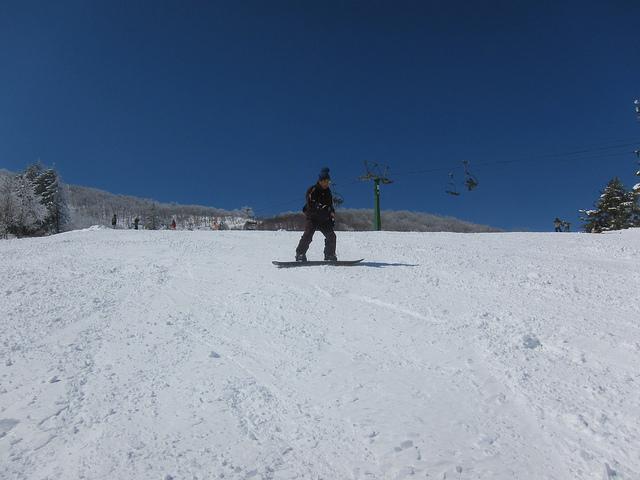How many skiers are there?
Give a very brief answer. 1. How many people are there in the photo?
Give a very brief answer. 1. 